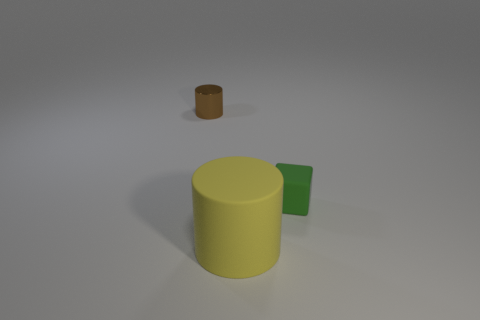Add 3 blue metallic cubes. How many objects exist? 6 Subtract all cylinders. How many objects are left? 1 Add 2 gray shiny spheres. How many gray shiny spheres exist? 2 Subtract 0 red spheres. How many objects are left? 3 Subtract all tiny brown metal spheres. Subtract all green rubber cubes. How many objects are left? 2 Add 3 brown cylinders. How many brown cylinders are left? 4 